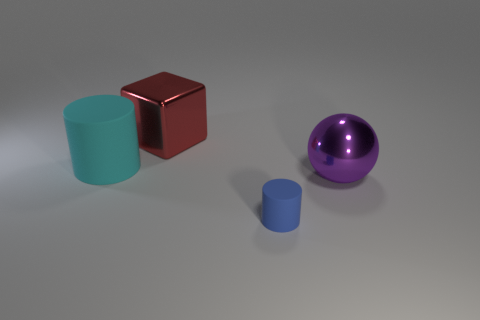Are there any other things that have the same size as the blue matte cylinder?
Make the answer very short. No. How many blue things are in front of the thing to the left of the big red shiny object?
Keep it short and to the point. 1. How many other things are the same size as the blue rubber object?
Provide a succinct answer. 0. Is the color of the large cylinder the same as the shiny cube?
Your answer should be compact. No. Is the shape of the metal object that is left of the tiny rubber cylinder the same as  the big cyan rubber thing?
Make the answer very short. No. What number of objects are both in front of the purple metallic sphere and left of the tiny cylinder?
Ensure brevity in your answer.  0. What is the purple sphere made of?
Give a very brief answer. Metal. Is there any other thing of the same color as the tiny rubber object?
Keep it short and to the point. No. Do the big red thing and the tiny blue cylinder have the same material?
Provide a succinct answer. No. There is a cylinder that is left of the matte thing in front of the purple thing; what number of large purple balls are behind it?
Offer a terse response. 0. 